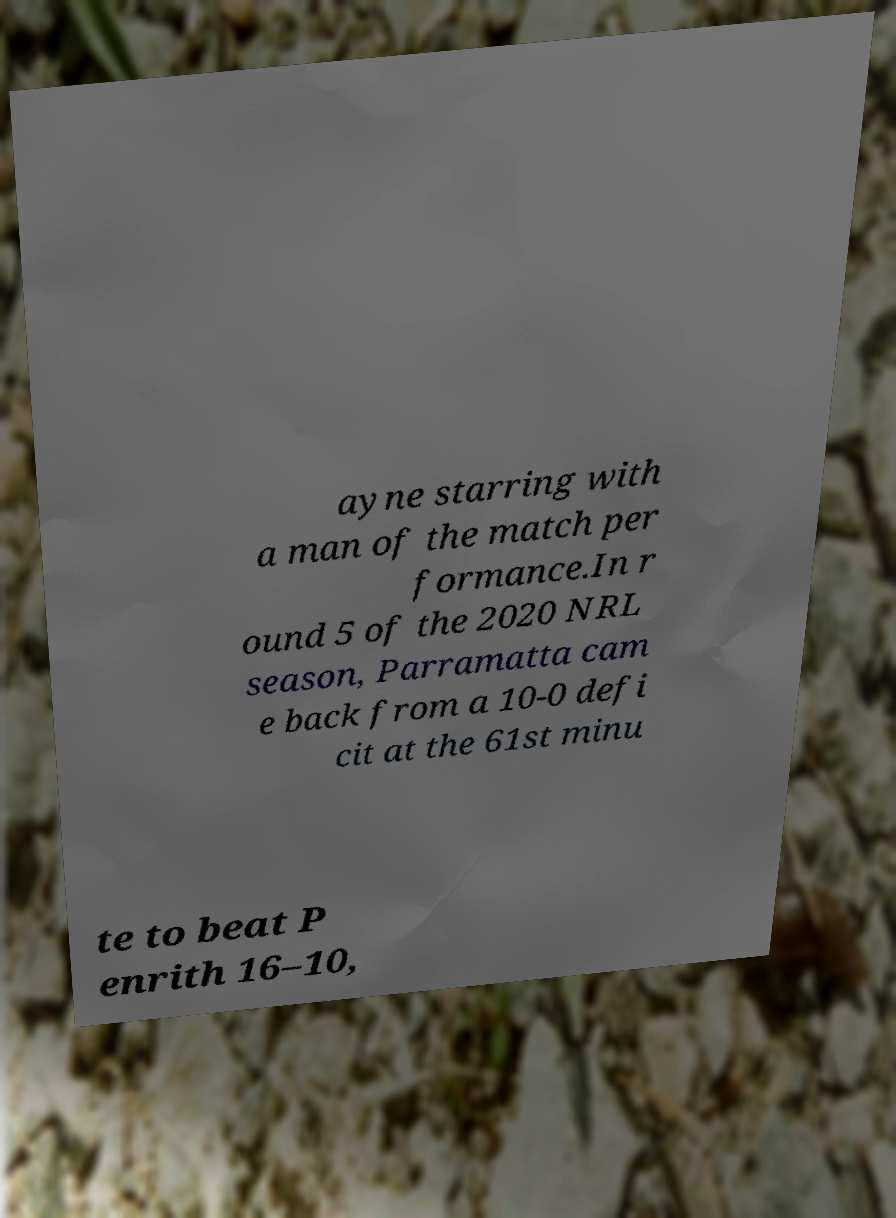Please read and relay the text visible in this image. What does it say? ayne starring with a man of the match per formance.In r ound 5 of the 2020 NRL season, Parramatta cam e back from a 10-0 defi cit at the 61st minu te to beat P enrith 16–10, 